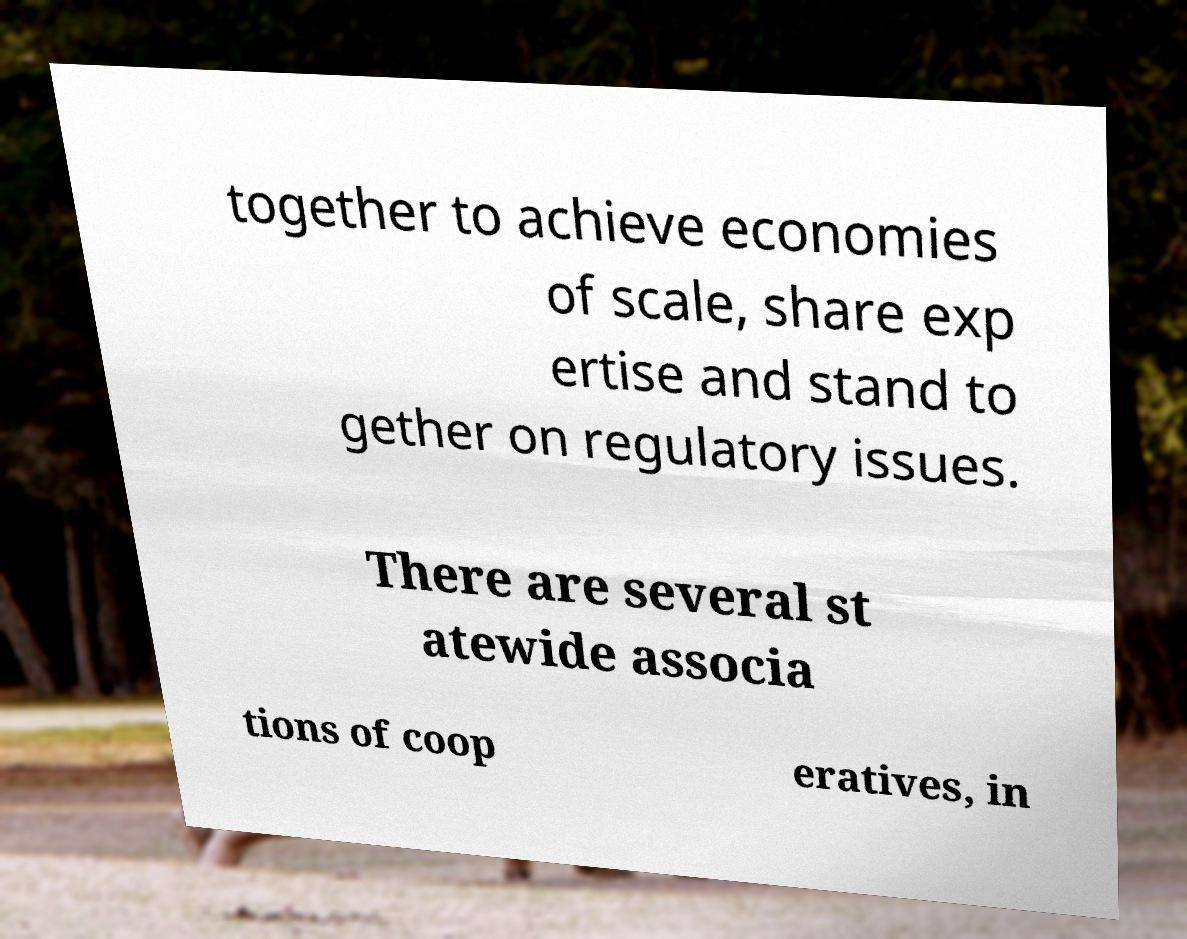Can you read and provide the text displayed in the image?This photo seems to have some interesting text. Can you extract and type it out for me? together to achieve economies of scale, share exp ertise and stand to gether on regulatory issues. There are several st atewide associa tions of coop eratives, in 